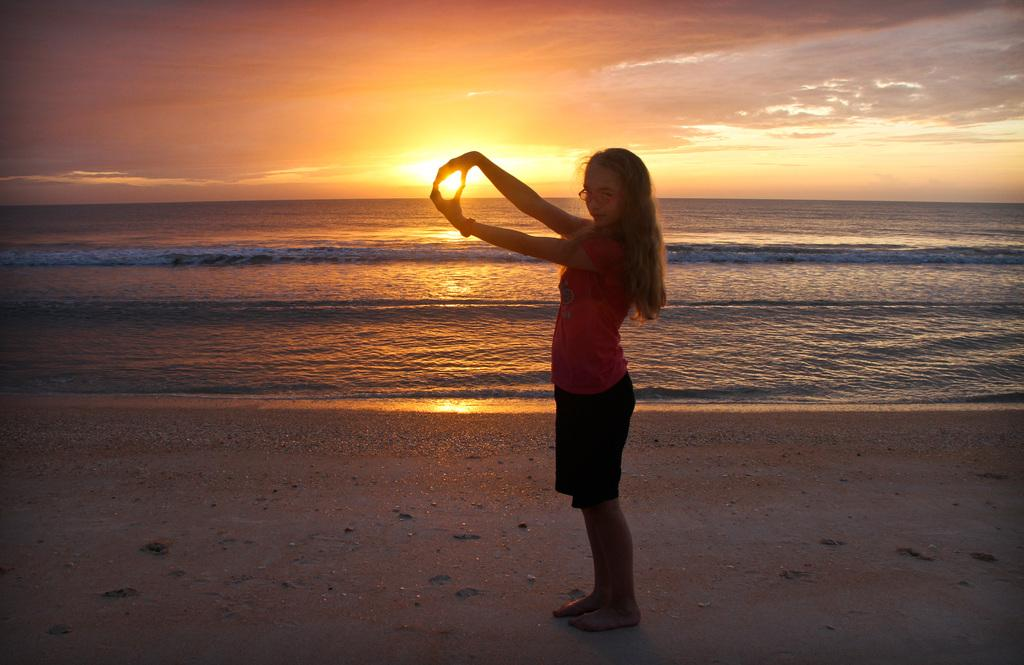What is the main subject of the image? There is a person standing in the image. What can be seen in the background of the image? The sky is visible in the image. What colors are present in the sky? The sky has orange, yellow, and white colors. What natural element is visible in the image? There is water visible in the image. What type of bear can be seen swimming in the water in the image? There is no bear present in the image; it only features a person standing and water visible. 